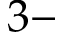<formula> <loc_0><loc_0><loc_500><loc_500>3 -</formula> 